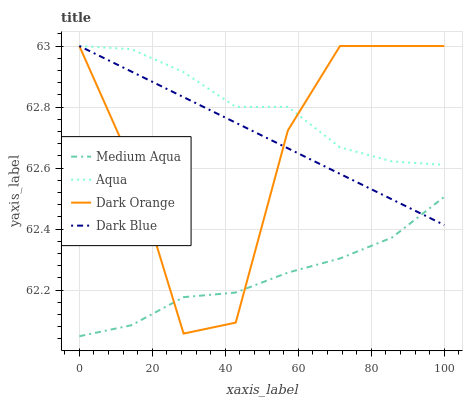Does Dark Blue have the minimum area under the curve?
Answer yes or no. No. Does Dark Blue have the maximum area under the curve?
Answer yes or no. No. Is Medium Aqua the smoothest?
Answer yes or no. No. Is Medium Aqua the roughest?
Answer yes or no. No. Does Dark Blue have the lowest value?
Answer yes or no. No. Does Medium Aqua have the highest value?
Answer yes or no. No. Is Medium Aqua less than Aqua?
Answer yes or no. Yes. Is Aqua greater than Medium Aqua?
Answer yes or no. Yes. Does Medium Aqua intersect Aqua?
Answer yes or no. No. 